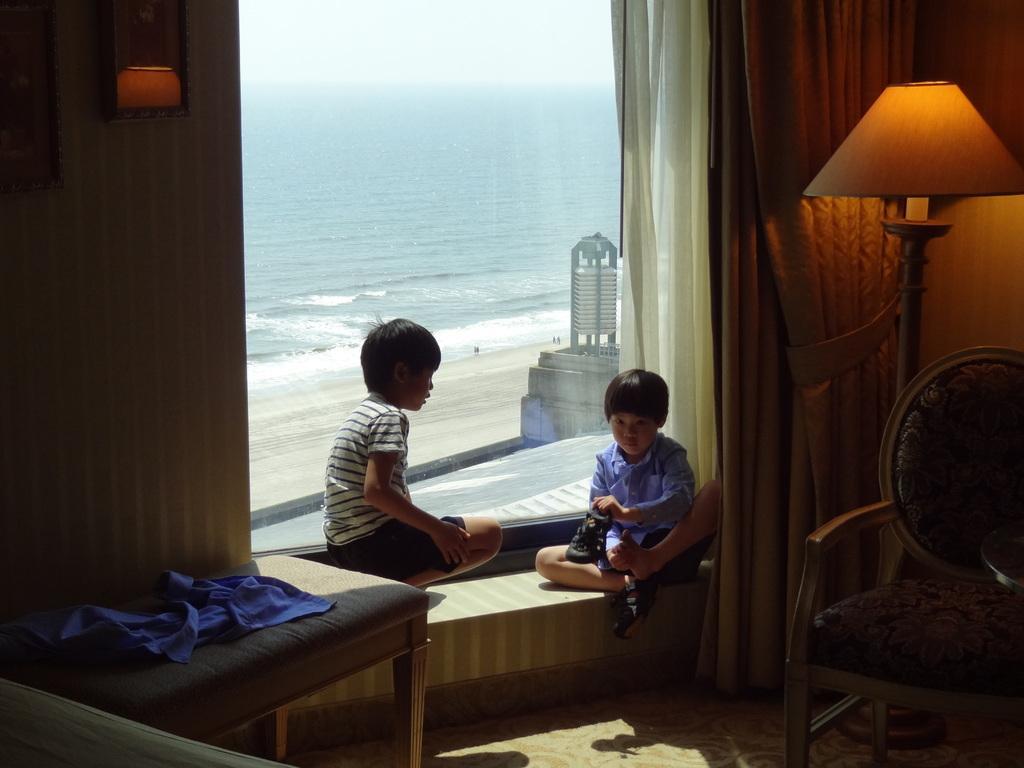Please provide a concise description of this image. This image is clicked inside a room. There is a beach ,there is a lamp on the left side corner and there is also a lamp on the right side corner, there is a chair on the right side corner ,there is table on the left side which has a cloth on it ,there are two kids sitting in the middle ,behind them there is a white curtain. 